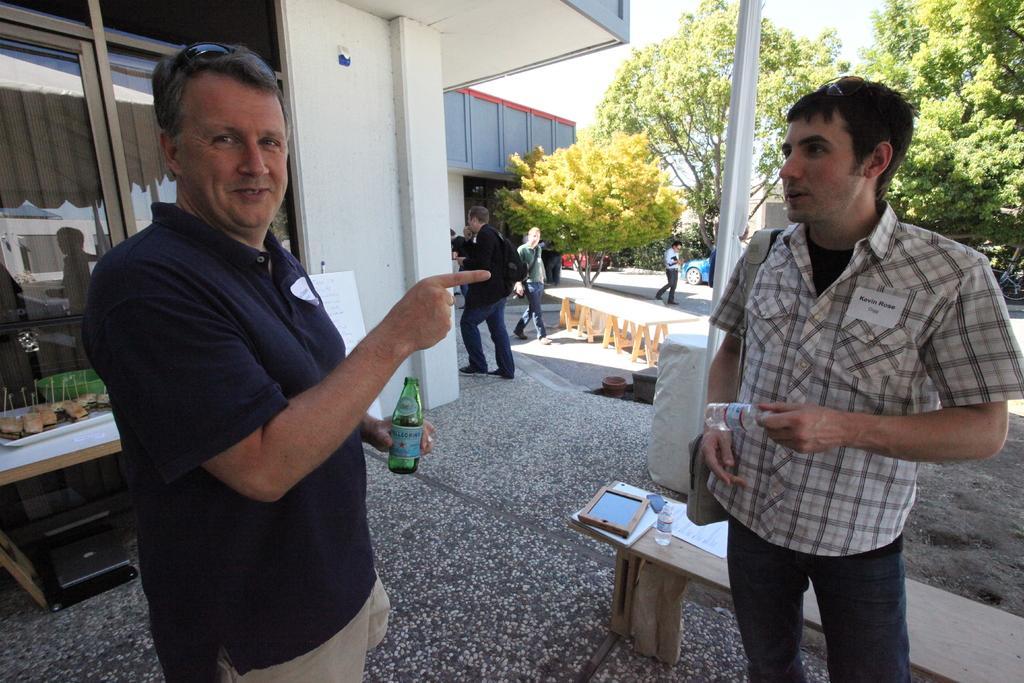Describe this image in one or two sentences. In this picture there are group of person standing. The man at the left side wearing blue colour t-shirt is having smile on his face and holding a bottle in his hand. The man at the right side is standing and holding a bottle in his hand. In the background there are persons standing and walking. There are some trees, sky, building, wall, windows, bench and on the bench there are papers, bottle, frame. 